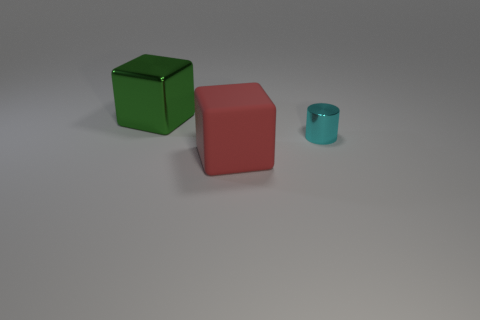Add 1 brown things. How many objects exist? 4 Subtract all cubes. How many objects are left? 1 Subtract 1 cubes. How many cubes are left? 1 Subtract all brown cylinders. Subtract all gray blocks. How many cylinders are left? 1 Subtract all blue cylinders. How many green blocks are left? 1 Subtract all yellow matte cylinders. Subtract all green metallic things. How many objects are left? 2 Add 1 tiny cyan things. How many tiny cyan things are left? 2 Add 2 small cyan metal cylinders. How many small cyan metal cylinders exist? 3 Subtract all green cubes. How many cubes are left? 1 Subtract 0 yellow cubes. How many objects are left? 3 